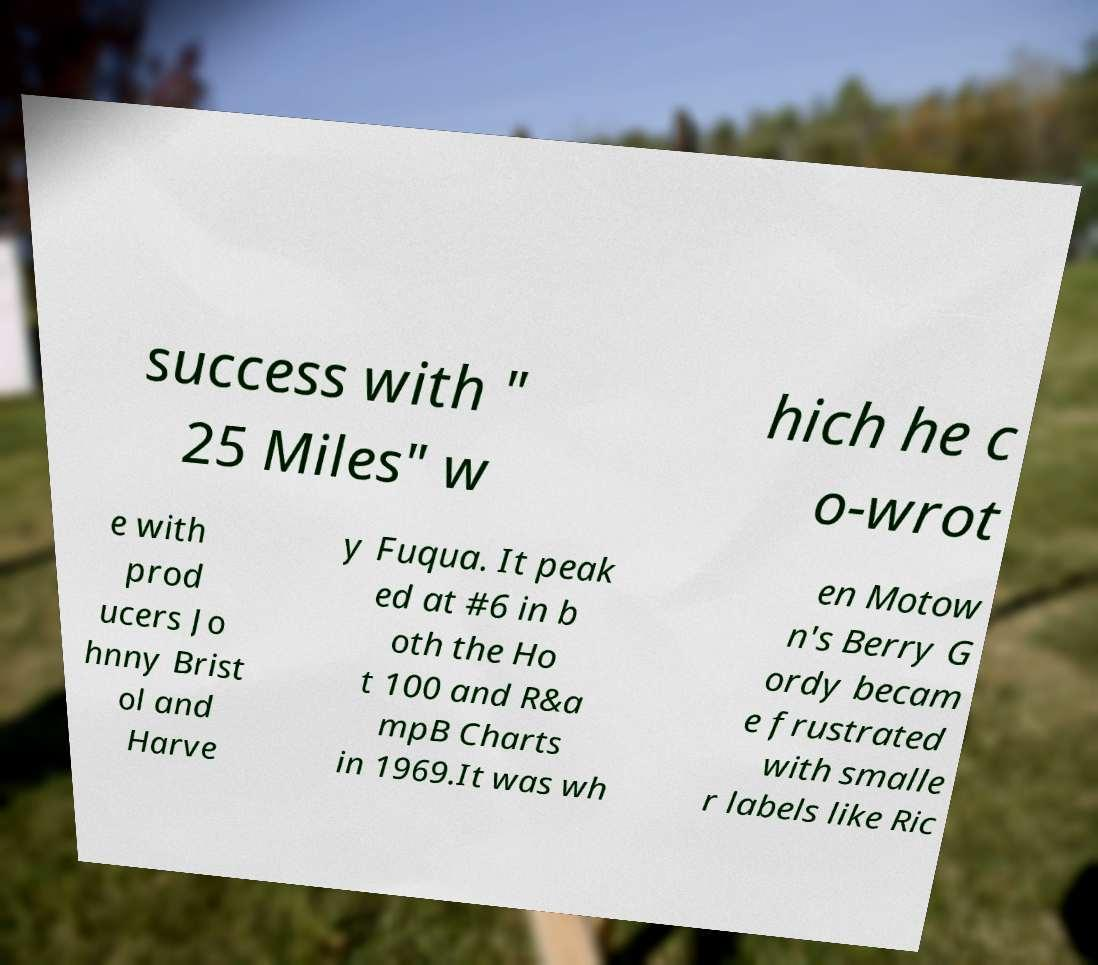Could you extract and type out the text from this image? success with " 25 Miles" w hich he c o-wrot e with prod ucers Jo hnny Brist ol and Harve y Fuqua. It peak ed at #6 in b oth the Ho t 100 and R&a mpB Charts in 1969.It was wh en Motow n's Berry G ordy becam e frustrated with smalle r labels like Ric 